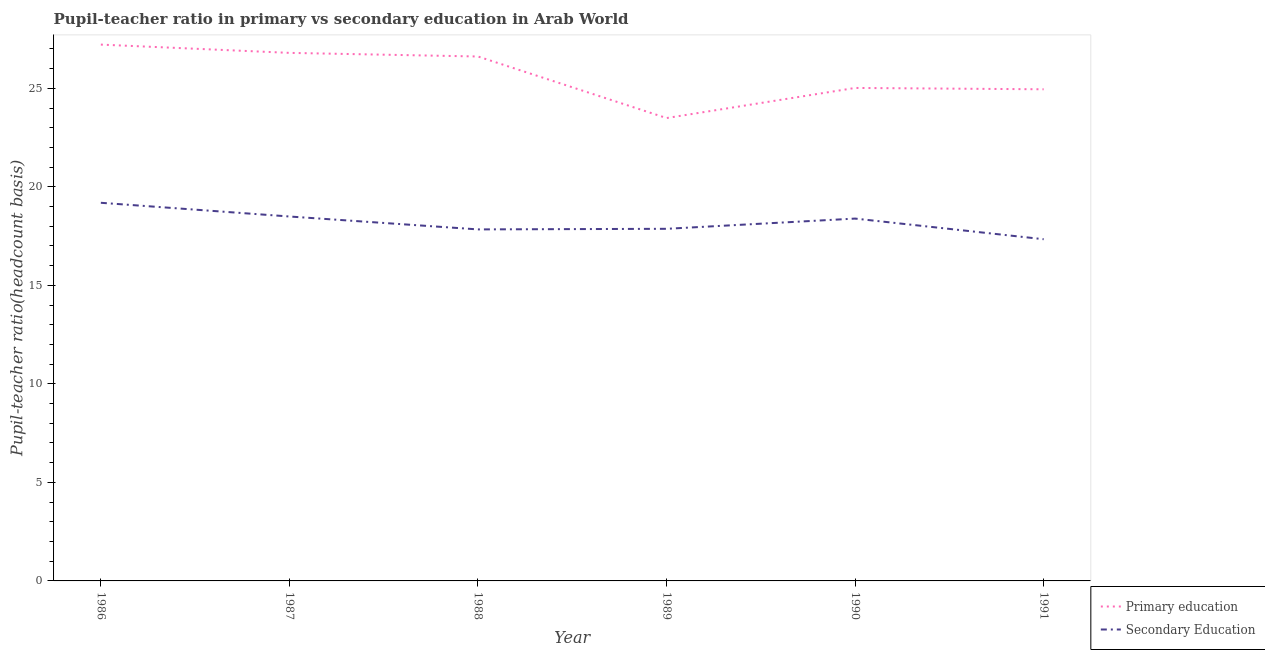How many different coloured lines are there?
Give a very brief answer. 2. What is the pupil teacher ratio on secondary education in 1988?
Give a very brief answer. 17.84. Across all years, what is the maximum pupil-teacher ratio in primary education?
Provide a succinct answer. 27.22. Across all years, what is the minimum pupil teacher ratio on secondary education?
Ensure brevity in your answer.  17.34. What is the total pupil-teacher ratio in primary education in the graph?
Your answer should be very brief. 154.09. What is the difference between the pupil-teacher ratio in primary education in 1987 and that in 1991?
Your answer should be very brief. 1.85. What is the difference between the pupil-teacher ratio in primary education in 1989 and the pupil teacher ratio on secondary education in 1986?
Offer a very short reply. 4.3. What is the average pupil teacher ratio on secondary education per year?
Offer a terse response. 18.19. In the year 1991, what is the difference between the pupil teacher ratio on secondary education and pupil-teacher ratio in primary education?
Make the answer very short. -7.61. In how many years, is the pupil-teacher ratio in primary education greater than 13?
Your response must be concise. 6. What is the ratio of the pupil-teacher ratio in primary education in 1986 to that in 1988?
Provide a short and direct response. 1.02. What is the difference between the highest and the second highest pupil teacher ratio on secondary education?
Give a very brief answer. 0.7. What is the difference between the highest and the lowest pupil teacher ratio on secondary education?
Make the answer very short. 1.85. Is the pupil teacher ratio on secondary education strictly greater than the pupil-teacher ratio in primary education over the years?
Your answer should be compact. No. Is the pupil teacher ratio on secondary education strictly less than the pupil-teacher ratio in primary education over the years?
Offer a terse response. Yes. How many years are there in the graph?
Make the answer very short. 6. What is the difference between two consecutive major ticks on the Y-axis?
Give a very brief answer. 5. Does the graph contain grids?
Provide a succinct answer. No. Where does the legend appear in the graph?
Make the answer very short. Bottom right. How many legend labels are there?
Your response must be concise. 2. What is the title of the graph?
Provide a succinct answer. Pupil-teacher ratio in primary vs secondary education in Arab World. What is the label or title of the Y-axis?
Ensure brevity in your answer.  Pupil-teacher ratio(headcount basis). What is the Pupil-teacher ratio(headcount basis) in Primary education in 1986?
Make the answer very short. 27.22. What is the Pupil-teacher ratio(headcount basis) in Secondary Education in 1986?
Keep it short and to the point. 19.19. What is the Pupil-teacher ratio(headcount basis) of Primary education in 1987?
Offer a very short reply. 26.8. What is the Pupil-teacher ratio(headcount basis) of Secondary Education in 1987?
Give a very brief answer. 18.49. What is the Pupil-teacher ratio(headcount basis) of Primary education in 1988?
Offer a terse response. 26.61. What is the Pupil-teacher ratio(headcount basis) in Secondary Education in 1988?
Your response must be concise. 17.84. What is the Pupil-teacher ratio(headcount basis) of Primary education in 1989?
Provide a short and direct response. 23.49. What is the Pupil-teacher ratio(headcount basis) in Secondary Education in 1989?
Ensure brevity in your answer.  17.87. What is the Pupil-teacher ratio(headcount basis) of Primary education in 1990?
Ensure brevity in your answer.  25.02. What is the Pupil-teacher ratio(headcount basis) in Secondary Education in 1990?
Give a very brief answer. 18.39. What is the Pupil-teacher ratio(headcount basis) of Primary education in 1991?
Give a very brief answer. 24.95. What is the Pupil-teacher ratio(headcount basis) in Secondary Education in 1991?
Your answer should be very brief. 17.34. Across all years, what is the maximum Pupil-teacher ratio(headcount basis) of Primary education?
Give a very brief answer. 27.22. Across all years, what is the maximum Pupil-teacher ratio(headcount basis) of Secondary Education?
Give a very brief answer. 19.19. Across all years, what is the minimum Pupil-teacher ratio(headcount basis) of Primary education?
Make the answer very short. 23.49. Across all years, what is the minimum Pupil-teacher ratio(headcount basis) of Secondary Education?
Give a very brief answer. 17.34. What is the total Pupil-teacher ratio(headcount basis) in Primary education in the graph?
Your answer should be compact. 154.09. What is the total Pupil-teacher ratio(headcount basis) of Secondary Education in the graph?
Ensure brevity in your answer.  109.13. What is the difference between the Pupil-teacher ratio(headcount basis) in Primary education in 1986 and that in 1987?
Make the answer very short. 0.42. What is the difference between the Pupil-teacher ratio(headcount basis) of Secondary Education in 1986 and that in 1987?
Your answer should be compact. 0.7. What is the difference between the Pupil-teacher ratio(headcount basis) in Primary education in 1986 and that in 1988?
Offer a very short reply. 0.6. What is the difference between the Pupil-teacher ratio(headcount basis) of Secondary Education in 1986 and that in 1988?
Ensure brevity in your answer.  1.35. What is the difference between the Pupil-teacher ratio(headcount basis) of Primary education in 1986 and that in 1989?
Your response must be concise. 3.73. What is the difference between the Pupil-teacher ratio(headcount basis) in Secondary Education in 1986 and that in 1989?
Give a very brief answer. 1.32. What is the difference between the Pupil-teacher ratio(headcount basis) in Primary education in 1986 and that in 1990?
Your response must be concise. 2.2. What is the difference between the Pupil-teacher ratio(headcount basis) of Secondary Education in 1986 and that in 1990?
Offer a terse response. 0.8. What is the difference between the Pupil-teacher ratio(headcount basis) in Primary education in 1986 and that in 1991?
Ensure brevity in your answer.  2.27. What is the difference between the Pupil-teacher ratio(headcount basis) of Secondary Education in 1986 and that in 1991?
Offer a terse response. 1.85. What is the difference between the Pupil-teacher ratio(headcount basis) of Primary education in 1987 and that in 1988?
Your answer should be compact. 0.18. What is the difference between the Pupil-teacher ratio(headcount basis) of Secondary Education in 1987 and that in 1988?
Keep it short and to the point. 0.65. What is the difference between the Pupil-teacher ratio(headcount basis) of Primary education in 1987 and that in 1989?
Keep it short and to the point. 3.31. What is the difference between the Pupil-teacher ratio(headcount basis) in Secondary Education in 1987 and that in 1989?
Provide a succinct answer. 0.62. What is the difference between the Pupil-teacher ratio(headcount basis) in Primary education in 1987 and that in 1990?
Offer a very short reply. 1.78. What is the difference between the Pupil-teacher ratio(headcount basis) in Secondary Education in 1987 and that in 1990?
Your response must be concise. 0.11. What is the difference between the Pupil-teacher ratio(headcount basis) in Primary education in 1987 and that in 1991?
Your answer should be compact. 1.85. What is the difference between the Pupil-teacher ratio(headcount basis) of Secondary Education in 1987 and that in 1991?
Keep it short and to the point. 1.15. What is the difference between the Pupil-teacher ratio(headcount basis) in Primary education in 1988 and that in 1989?
Your answer should be compact. 3.12. What is the difference between the Pupil-teacher ratio(headcount basis) of Secondary Education in 1988 and that in 1989?
Offer a very short reply. -0.03. What is the difference between the Pupil-teacher ratio(headcount basis) of Primary education in 1988 and that in 1990?
Make the answer very short. 1.6. What is the difference between the Pupil-teacher ratio(headcount basis) of Secondary Education in 1988 and that in 1990?
Your answer should be compact. -0.55. What is the difference between the Pupil-teacher ratio(headcount basis) of Primary education in 1988 and that in 1991?
Offer a terse response. 1.66. What is the difference between the Pupil-teacher ratio(headcount basis) of Secondary Education in 1988 and that in 1991?
Provide a succinct answer. 0.5. What is the difference between the Pupil-teacher ratio(headcount basis) of Primary education in 1989 and that in 1990?
Your answer should be very brief. -1.53. What is the difference between the Pupil-teacher ratio(headcount basis) in Secondary Education in 1989 and that in 1990?
Keep it short and to the point. -0.52. What is the difference between the Pupil-teacher ratio(headcount basis) in Primary education in 1989 and that in 1991?
Give a very brief answer. -1.46. What is the difference between the Pupil-teacher ratio(headcount basis) in Secondary Education in 1989 and that in 1991?
Make the answer very short. 0.53. What is the difference between the Pupil-teacher ratio(headcount basis) of Primary education in 1990 and that in 1991?
Your response must be concise. 0.07. What is the difference between the Pupil-teacher ratio(headcount basis) of Secondary Education in 1990 and that in 1991?
Ensure brevity in your answer.  1.05. What is the difference between the Pupil-teacher ratio(headcount basis) in Primary education in 1986 and the Pupil-teacher ratio(headcount basis) in Secondary Education in 1987?
Keep it short and to the point. 8.72. What is the difference between the Pupil-teacher ratio(headcount basis) of Primary education in 1986 and the Pupil-teacher ratio(headcount basis) of Secondary Education in 1988?
Give a very brief answer. 9.38. What is the difference between the Pupil-teacher ratio(headcount basis) of Primary education in 1986 and the Pupil-teacher ratio(headcount basis) of Secondary Education in 1989?
Keep it short and to the point. 9.35. What is the difference between the Pupil-teacher ratio(headcount basis) of Primary education in 1986 and the Pupil-teacher ratio(headcount basis) of Secondary Education in 1990?
Give a very brief answer. 8.83. What is the difference between the Pupil-teacher ratio(headcount basis) of Primary education in 1986 and the Pupil-teacher ratio(headcount basis) of Secondary Education in 1991?
Keep it short and to the point. 9.88. What is the difference between the Pupil-teacher ratio(headcount basis) of Primary education in 1987 and the Pupil-teacher ratio(headcount basis) of Secondary Education in 1988?
Your response must be concise. 8.96. What is the difference between the Pupil-teacher ratio(headcount basis) of Primary education in 1987 and the Pupil-teacher ratio(headcount basis) of Secondary Education in 1989?
Offer a terse response. 8.93. What is the difference between the Pupil-teacher ratio(headcount basis) of Primary education in 1987 and the Pupil-teacher ratio(headcount basis) of Secondary Education in 1990?
Your answer should be very brief. 8.41. What is the difference between the Pupil-teacher ratio(headcount basis) of Primary education in 1987 and the Pupil-teacher ratio(headcount basis) of Secondary Education in 1991?
Provide a short and direct response. 9.46. What is the difference between the Pupil-teacher ratio(headcount basis) of Primary education in 1988 and the Pupil-teacher ratio(headcount basis) of Secondary Education in 1989?
Offer a very short reply. 8.74. What is the difference between the Pupil-teacher ratio(headcount basis) in Primary education in 1988 and the Pupil-teacher ratio(headcount basis) in Secondary Education in 1990?
Your answer should be compact. 8.23. What is the difference between the Pupil-teacher ratio(headcount basis) of Primary education in 1988 and the Pupil-teacher ratio(headcount basis) of Secondary Education in 1991?
Provide a succinct answer. 9.27. What is the difference between the Pupil-teacher ratio(headcount basis) in Primary education in 1989 and the Pupil-teacher ratio(headcount basis) in Secondary Education in 1990?
Provide a short and direct response. 5.1. What is the difference between the Pupil-teacher ratio(headcount basis) of Primary education in 1989 and the Pupil-teacher ratio(headcount basis) of Secondary Education in 1991?
Your answer should be compact. 6.15. What is the difference between the Pupil-teacher ratio(headcount basis) in Primary education in 1990 and the Pupil-teacher ratio(headcount basis) in Secondary Education in 1991?
Provide a succinct answer. 7.68. What is the average Pupil-teacher ratio(headcount basis) in Primary education per year?
Ensure brevity in your answer.  25.68. What is the average Pupil-teacher ratio(headcount basis) in Secondary Education per year?
Make the answer very short. 18.19. In the year 1986, what is the difference between the Pupil-teacher ratio(headcount basis) in Primary education and Pupil-teacher ratio(headcount basis) in Secondary Education?
Give a very brief answer. 8.03. In the year 1987, what is the difference between the Pupil-teacher ratio(headcount basis) of Primary education and Pupil-teacher ratio(headcount basis) of Secondary Education?
Offer a very short reply. 8.3. In the year 1988, what is the difference between the Pupil-teacher ratio(headcount basis) in Primary education and Pupil-teacher ratio(headcount basis) in Secondary Education?
Give a very brief answer. 8.77. In the year 1989, what is the difference between the Pupil-teacher ratio(headcount basis) of Primary education and Pupil-teacher ratio(headcount basis) of Secondary Education?
Ensure brevity in your answer.  5.62. In the year 1990, what is the difference between the Pupil-teacher ratio(headcount basis) of Primary education and Pupil-teacher ratio(headcount basis) of Secondary Education?
Your response must be concise. 6.63. In the year 1991, what is the difference between the Pupil-teacher ratio(headcount basis) in Primary education and Pupil-teacher ratio(headcount basis) in Secondary Education?
Your response must be concise. 7.61. What is the ratio of the Pupil-teacher ratio(headcount basis) in Primary education in 1986 to that in 1987?
Offer a terse response. 1.02. What is the ratio of the Pupil-teacher ratio(headcount basis) in Secondary Education in 1986 to that in 1987?
Provide a succinct answer. 1.04. What is the ratio of the Pupil-teacher ratio(headcount basis) of Primary education in 1986 to that in 1988?
Provide a succinct answer. 1.02. What is the ratio of the Pupil-teacher ratio(headcount basis) of Secondary Education in 1986 to that in 1988?
Keep it short and to the point. 1.08. What is the ratio of the Pupil-teacher ratio(headcount basis) in Primary education in 1986 to that in 1989?
Offer a terse response. 1.16. What is the ratio of the Pupil-teacher ratio(headcount basis) of Secondary Education in 1986 to that in 1989?
Provide a succinct answer. 1.07. What is the ratio of the Pupil-teacher ratio(headcount basis) of Primary education in 1986 to that in 1990?
Your response must be concise. 1.09. What is the ratio of the Pupil-teacher ratio(headcount basis) of Secondary Education in 1986 to that in 1990?
Give a very brief answer. 1.04. What is the ratio of the Pupil-teacher ratio(headcount basis) in Primary education in 1986 to that in 1991?
Keep it short and to the point. 1.09. What is the ratio of the Pupil-teacher ratio(headcount basis) in Secondary Education in 1986 to that in 1991?
Offer a terse response. 1.11. What is the ratio of the Pupil-teacher ratio(headcount basis) in Primary education in 1987 to that in 1988?
Offer a terse response. 1.01. What is the ratio of the Pupil-teacher ratio(headcount basis) in Secondary Education in 1987 to that in 1988?
Provide a succinct answer. 1.04. What is the ratio of the Pupil-teacher ratio(headcount basis) of Primary education in 1987 to that in 1989?
Your answer should be compact. 1.14. What is the ratio of the Pupil-teacher ratio(headcount basis) in Secondary Education in 1987 to that in 1989?
Your answer should be very brief. 1.03. What is the ratio of the Pupil-teacher ratio(headcount basis) in Primary education in 1987 to that in 1990?
Provide a succinct answer. 1.07. What is the ratio of the Pupil-teacher ratio(headcount basis) of Primary education in 1987 to that in 1991?
Keep it short and to the point. 1.07. What is the ratio of the Pupil-teacher ratio(headcount basis) in Secondary Education in 1987 to that in 1991?
Offer a terse response. 1.07. What is the ratio of the Pupil-teacher ratio(headcount basis) of Primary education in 1988 to that in 1989?
Provide a short and direct response. 1.13. What is the ratio of the Pupil-teacher ratio(headcount basis) of Primary education in 1988 to that in 1990?
Your answer should be very brief. 1.06. What is the ratio of the Pupil-teacher ratio(headcount basis) of Secondary Education in 1988 to that in 1990?
Provide a short and direct response. 0.97. What is the ratio of the Pupil-teacher ratio(headcount basis) of Primary education in 1988 to that in 1991?
Ensure brevity in your answer.  1.07. What is the ratio of the Pupil-teacher ratio(headcount basis) of Secondary Education in 1988 to that in 1991?
Your response must be concise. 1.03. What is the ratio of the Pupil-teacher ratio(headcount basis) of Primary education in 1989 to that in 1990?
Provide a succinct answer. 0.94. What is the ratio of the Pupil-teacher ratio(headcount basis) of Secondary Education in 1989 to that in 1990?
Make the answer very short. 0.97. What is the ratio of the Pupil-teacher ratio(headcount basis) of Primary education in 1989 to that in 1991?
Keep it short and to the point. 0.94. What is the ratio of the Pupil-teacher ratio(headcount basis) of Secondary Education in 1989 to that in 1991?
Keep it short and to the point. 1.03. What is the ratio of the Pupil-teacher ratio(headcount basis) in Secondary Education in 1990 to that in 1991?
Make the answer very short. 1.06. What is the difference between the highest and the second highest Pupil-teacher ratio(headcount basis) in Primary education?
Give a very brief answer. 0.42. What is the difference between the highest and the second highest Pupil-teacher ratio(headcount basis) in Secondary Education?
Ensure brevity in your answer.  0.7. What is the difference between the highest and the lowest Pupil-teacher ratio(headcount basis) in Primary education?
Offer a very short reply. 3.73. What is the difference between the highest and the lowest Pupil-teacher ratio(headcount basis) of Secondary Education?
Provide a short and direct response. 1.85. 